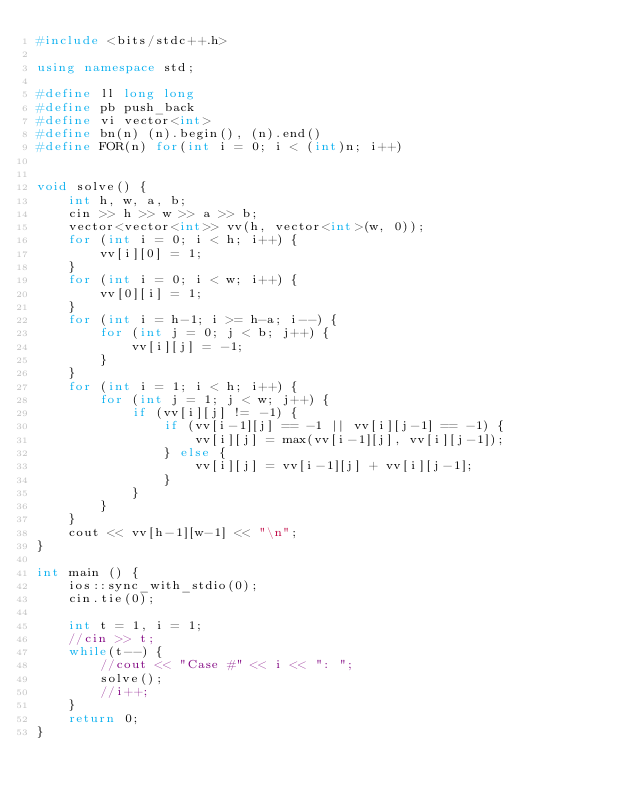<code> <loc_0><loc_0><loc_500><loc_500><_C++_>#include <bits/stdc++.h>

using namespace std;

#define ll long long
#define pb push_back
#define vi vector<int>
#define bn(n) (n).begin(), (n).end()
#define FOR(n) for(int i = 0; i < (int)n; i++)


void solve() {
    int h, w, a, b;
    cin >> h >> w >> a >> b;
    vector<vector<int>> vv(h, vector<int>(w, 0));
    for (int i = 0; i < h; i++) {
        vv[i][0] = 1;
    }
    for (int i = 0; i < w; i++) {
        vv[0][i] = 1;
    }
    for (int i = h-1; i >= h-a; i--) {
        for (int j = 0; j < b; j++) {
            vv[i][j] = -1;
        }
    }
    for (int i = 1; i < h; i++) {
        for (int j = 1; j < w; j++) {
            if (vv[i][j] != -1) {
                if (vv[i-1][j] == -1 || vv[i][j-1] == -1) {
                    vv[i][j] = max(vv[i-1][j], vv[i][j-1]);
                } else {
                    vv[i][j] = vv[i-1][j] + vv[i][j-1];
                }
            }
        }
    }
    cout << vv[h-1][w-1] << "\n";
}

int main () {
    ios::sync_with_stdio(0);
    cin.tie(0);

    int t = 1, i = 1;
    //cin >> t;
    while(t--) {
        //cout << "Case #" << i << ": ";
        solve();
        //i++;
    }
    return 0;
}
</code> 